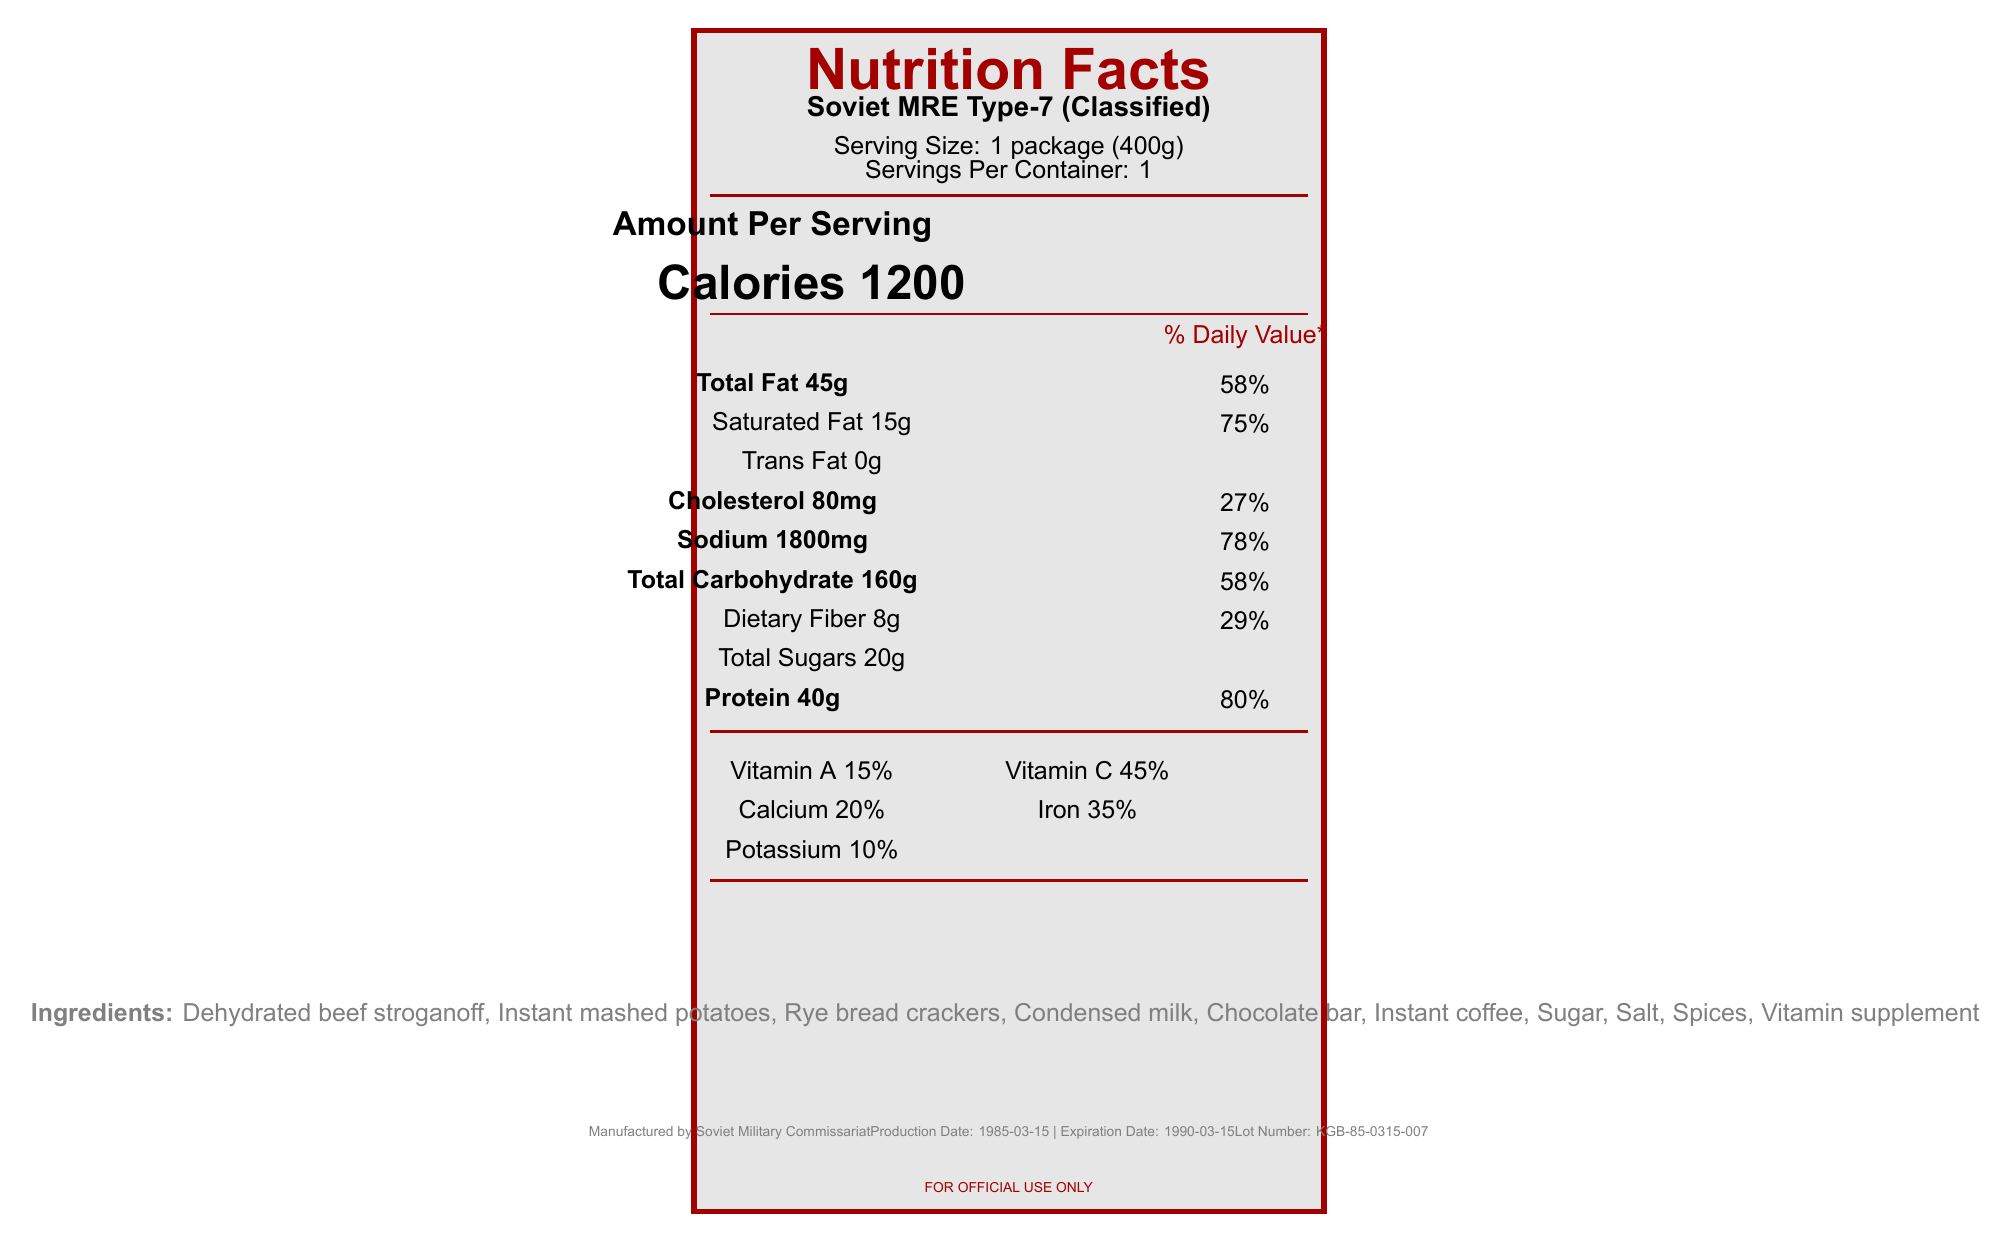What is the serving size for the Soviet MRE Type-7? The serving size is stated as "1 package (400g)" in the document.
Answer: 1 package (400g) How much protein is in one serving of this MRE? The document lists "Protein 40g" under the nutritional information.
Answer: 40g What is the percentage daily value of sodium in this MRE? The sodium percentage daily value is specified as "78%" in the document.
Answer: 78% What are the ingredients listed for the Soviet MRE Type-7? The ingredients are found under the "Ingredients" section of the document.
Answer: Dehydrated beef stroganoff, Instant mashed potatoes, Rye bread crackers, Condensed milk, Chocolate bar, Instant coffee, Sugar, Salt, Spices, Vitamin supplement What is the expiration date of this MRE? The expiration date is mentioned as "1990-03-15" in the manufacturing details.
Answer: 1990-03-15 Where is the hidden compartment located? The hidden compartment's location is specified as "Inside chocolate bar wrapper" under the hidden compartment details.
Answer: Inside chocolate bar wrapper What is the purpose of the foldable spoon included in the MRE? A. To eat the meal B. To operate as a hidden lock pick C. To serve as a multi-tool D. Both A and B The document mentions the spoon is for eating the meal and has a hidden lock pick in the handle.
Answer: D What is the caloric content per serving of the Soviet MRE Type-7? A. 900 calories B. 1000 calories C. 1200 calories The document states "Calories 1200" for the caloric content per serving.
Answer: C Does this MRE include any water purification tablets? The additional information mentions the inclusion of iodine tablets for water treatment.
Answer: Yes Summarize the main idea of the Soviet MRE Type-7 document. The document provides detailed nutritional facts, operational uses, hidden espionage tools, and composition of the Soviet MRE Type-7, highlighting its high-calorie content and additional covert features for Spetsnaz operatives.
Answer: The Soviet MRE Type-7 is a high-calorie meal designed for Spetsnaz operatives, featuring a variety of nutritional information, ingredients, and operational details including a hidden microfilm compartment in the chocolate bar wrapper. What is the percentage daily value of dietary fiber in this MRE? The document lists "Dietary Fiber 8g" and the daily value percentage as "29%".
Answer: 29% Is the Soviet MRE Type-7 suitable for someone monitoring their cholesterol intake? With 80mg of cholesterol accounting for 27% of the daily value, it may not be suitable for someone monitoring their cholesterol consumption.
Answer: No Can you tell me the exact dimensions of the microfilm compartment? The hidden compartment's dimensions are mentioned as "2cm x 1cm".
Answer: 2cm x 1cm What is the manufacturer's name? The manufacturer is stated as "Soviet Military Commissariat".
Answer: Soviet Military Commissariat Who is the primary intended user of this MRE? The additional information specifies that this MRE is designed for "Spetsnaz operatives in Western Europe".
Answer: Spetsnaz operatives in Western Europe What type of packaging does this MRE use? The packaging is described as a "Vacuum-sealed aluminum pouch".
Answer: Vacuum-sealed aluminum pouch Why is the packaging designed to mimic Western MREs? The additional information states that the packaging is designed to mimic Western MREs if discovered, for camouflage purposes.
Answer: Camouflage purposes What vitamins are listed in the nutritional facts? The vitamins listed are "Vitamin A 15%" and "Vitamin C 45%".
Answer: Vitamin A, Vitamin C What is the lot number of this MRE? The lot number is given as "KGB-85-0315-007".
Answer: KGB-85-0315-007 What type of lock is included in the handle? The document only mentions a hidden lock pick in the handle of the spoon, but does not specify the type of lock.
Answer: I don't know 